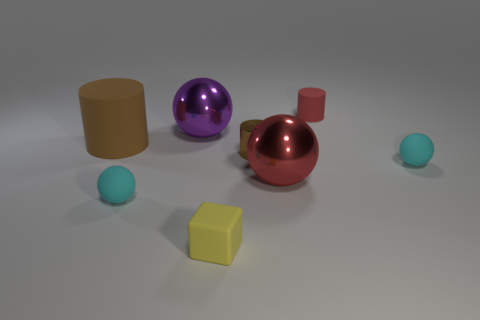Add 1 large brown rubber cylinders. How many objects exist? 9 Subtract all blocks. How many objects are left? 7 Subtract all large gray spheres. Subtract all brown matte cylinders. How many objects are left? 7 Add 1 yellow rubber things. How many yellow rubber things are left? 2 Add 3 cyan objects. How many cyan objects exist? 5 Subtract 0 brown cubes. How many objects are left? 8 